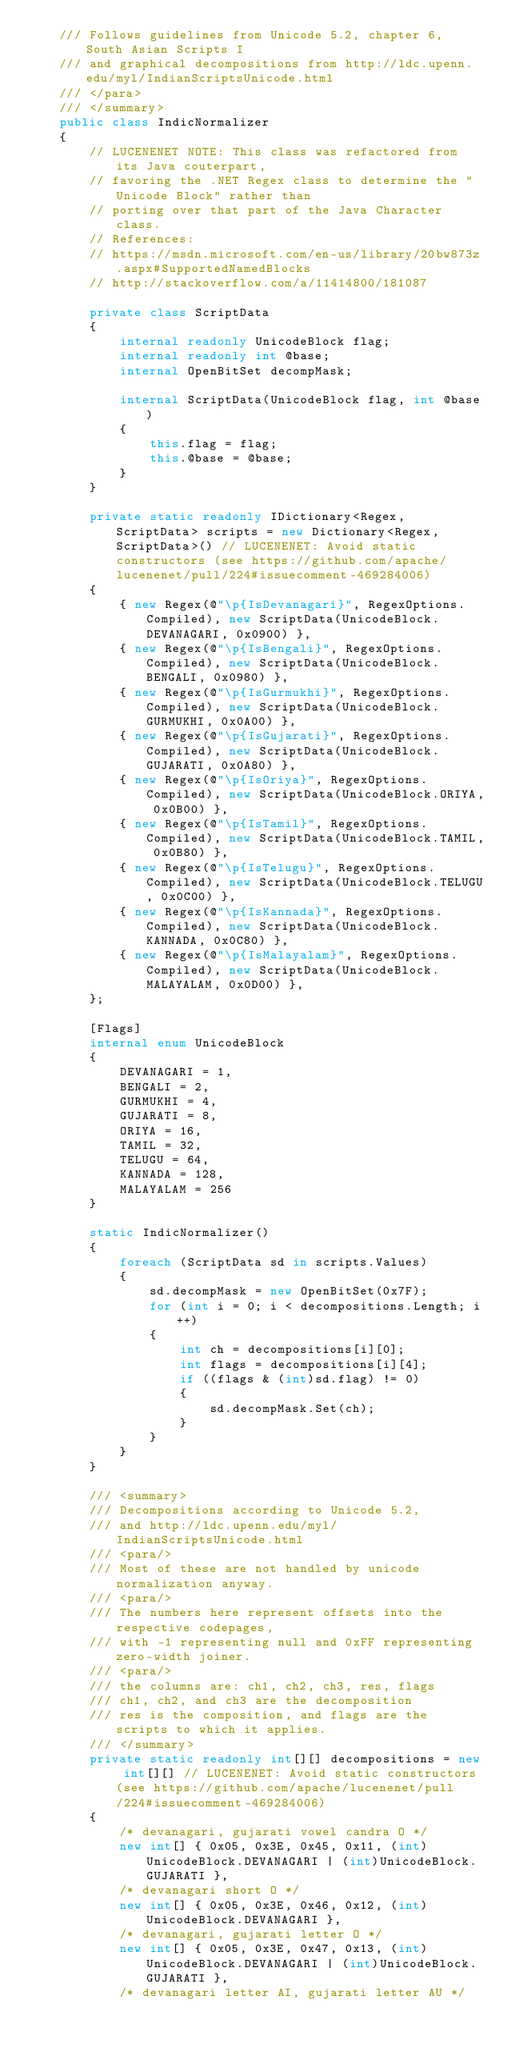Convert code to text. <code><loc_0><loc_0><loc_500><loc_500><_C#_>    /// Follows guidelines from Unicode 5.2, chapter 6, South Asian Scripts I
    /// and graphical decompositions from http://ldc.upenn.edu/myl/IndianScriptsUnicode.html
    /// </para>
    /// </summary>
    public class IndicNormalizer
    {
        // LUCENENET NOTE: This class was refactored from its Java couterpart,
        // favoring the .NET Regex class to determine the "Unicode Block" rather than 
        // porting over that part of the Java Character class.
        // References: 
        // https://msdn.microsoft.com/en-us/library/20bw873z.aspx#SupportedNamedBlocks
        // http://stackoverflow.com/a/11414800/181087

        private class ScriptData
        {
            internal readonly UnicodeBlock flag;
            internal readonly int @base;
            internal OpenBitSet decompMask;

            internal ScriptData(UnicodeBlock flag, int @base)
            {
                this.flag = flag;
                this.@base = @base;
            }
        }

        private static readonly IDictionary<Regex, ScriptData> scripts = new Dictionary<Regex, ScriptData>() // LUCENENET: Avoid static constructors (see https://github.com/apache/lucenenet/pull/224#issuecomment-469284006)
        {
            { new Regex(@"\p{IsDevanagari}", RegexOptions.Compiled), new ScriptData(UnicodeBlock.DEVANAGARI, 0x0900) },
            { new Regex(@"\p{IsBengali}", RegexOptions.Compiled), new ScriptData(UnicodeBlock.BENGALI, 0x0980) },
            { new Regex(@"\p{IsGurmukhi}", RegexOptions.Compiled), new ScriptData(UnicodeBlock.GURMUKHI, 0x0A00) },
            { new Regex(@"\p{IsGujarati}", RegexOptions.Compiled), new ScriptData(UnicodeBlock.GUJARATI, 0x0A80) },
            { new Regex(@"\p{IsOriya}", RegexOptions.Compiled), new ScriptData(UnicodeBlock.ORIYA, 0x0B00) },
            { new Regex(@"\p{IsTamil}", RegexOptions.Compiled), new ScriptData(UnicodeBlock.TAMIL, 0x0B80) },
            { new Regex(@"\p{IsTelugu}", RegexOptions.Compiled), new ScriptData(UnicodeBlock.TELUGU, 0x0C00) },
            { new Regex(@"\p{IsKannada}", RegexOptions.Compiled), new ScriptData(UnicodeBlock.KANNADA, 0x0C80) },
            { new Regex(@"\p{IsMalayalam}", RegexOptions.Compiled), new ScriptData(UnicodeBlock.MALAYALAM, 0x0D00) },
        };

        [Flags]
        internal enum UnicodeBlock
        {
            DEVANAGARI = 1,
            BENGALI = 2,
            GURMUKHI = 4,
            GUJARATI = 8,
            ORIYA = 16,
            TAMIL = 32,
            TELUGU = 64,
            KANNADA = 128,
            MALAYALAM = 256
        }

        static IndicNormalizer()
        {
            foreach (ScriptData sd in scripts.Values)
            {
                sd.decompMask = new OpenBitSet(0x7F);
                for (int i = 0; i < decompositions.Length; i++)
                {
                    int ch = decompositions[i][0];
                    int flags = decompositions[i][4];
                    if ((flags & (int)sd.flag) != 0)
                    {
                        sd.decompMask.Set(ch);
                    }
                }
            }
        }

        /// <summary>
        /// Decompositions according to Unicode 5.2, 
        /// and http://ldc.upenn.edu/myl/IndianScriptsUnicode.html
        /// <para/>
        /// Most of these are not handled by unicode normalization anyway.
        /// <para/>
        /// The numbers here represent offsets into the respective codepages,
        /// with -1 representing null and 0xFF representing zero-width joiner.
        /// <para/>
        /// the columns are: ch1, ch2, ch3, res, flags
        /// ch1, ch2, and ch3 are the decomposition
        /// res is the composition, and flags are the scripts to which it applies.
        /// </summary>
        private static readonly int[][] decompositions = new int[][] // LUCENENET: Avoid static constructors (see https://github.com/apache/lucenenet/pull/224#issuecomment-469284006)
        {
            /* devanagari, gujarati vowel candra O */
            new int[] { 0x05, 0x3E, 0x45, 0x11, (int)UnicodeBlock.DEVANAGARI | (int)UnicodeBlock.GUJARATI },
            /* devanagari short O */
            new int[] { 0x05, 0x3E, 0x46, 0x12, (int)UnicodeBlock.DEVANAGARI }, 
            /* devanagari, gujarati letter O */
            new int[] { 0x05, 0x3E, 0x47, 0x13, (int)UnicodeBlock.DEVANAGARI | (int)UnicodeBlock.GUJARATI },
            /* devanagari letter AI, gujarati letter AU */</code> 